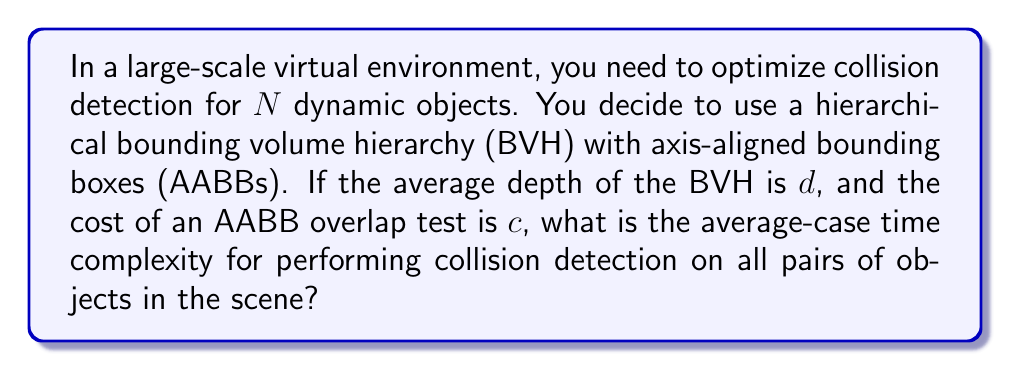Can you solve this math problem? To solve this problem, let's break it down into steps:

1) In a hierarchical BVH, we start at the root and traverse down the tree to find potentially colliding objects.

2) The average depth of the tree is $d$, which means on average, we need to perform $d$ AABB overlap tests to reach a leaf node.

3) For each object, we need to check against all other objects. This gives us $N$ traversals of the tree.

4) However, we don't need to check every object against every other object. Once we've checked object A against object B, we don't need to check B against A. This reduces our total number of checks to $\frac{N(N-1)}{2}$.

5) For each of these checks, we perform on average $d$ AABB overlap tests.

6) Each AABB overlap test costs $c$ operations.

7) Therefore, the total number of operations is:

   $$\frac{N(N-1)}{2} \cdot d \cdot c$$

8) In big O notation, we drop constant factors and lower-order terms. $c$ is a constant, and $N-1$ is approximately $N$ for large $N$.

9) This leaves us with:

   $$O(N^2 \cdot d)$$

10) The depth $d$ of a well-balanced tree is typically logarithmic in the number of objects, so $d \approx \log N$.

11) Substituting this in, we get:

    $$O(N^2 \log N)$$

This is the average-case time complexity for performing collision detection on all pairs of objects in the scene using a hierarchical BVH with AABBs.
Answer: $O(N^2 \log N)$ 